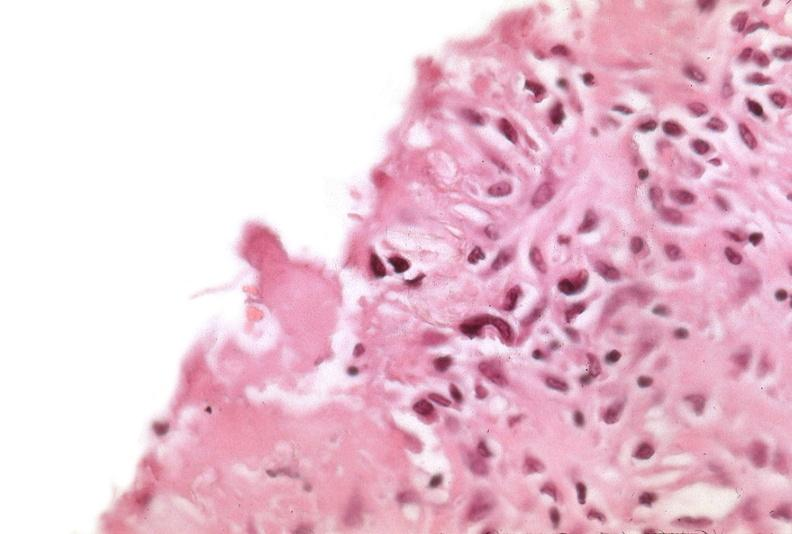how many antitrypsin was talc used to sclerose emphysematous lung, alpha-deficiency?
Answer the question using a single word or phrase. 1 